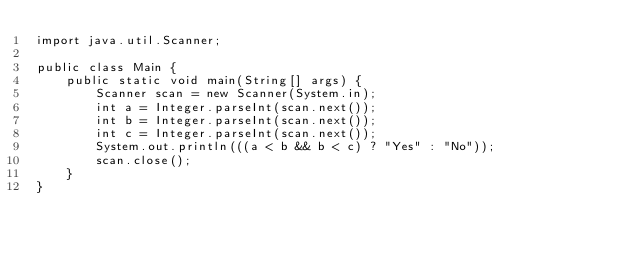Convert code to text. <code><loc_0><loc_0><loc_500><loc_500><_Java_>import java.util.Scanner;

public class Main {
	public static void main(String[] args) {
		Scanner scan = new Scanner(System.in);
		int a = Integer.parseInt(scan.next());
		int b = Integer.parseInt(scan.next());
		int c = Integer.parseInt(scan.next());
		System.out.println(((a < b && b < c) ? "Yes" : "No"));
		scan.close();
	}
}
</code> 